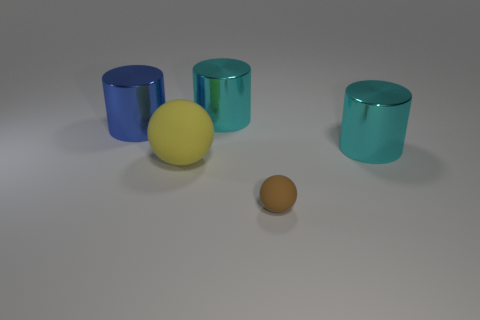Subtract all big blue cylinders. How many cylinders are left? 2 Add 4 large yellow rubber spheres. How many objects exist? 9 Subtract all yellow spheres. How many spheres are left? 1 Subtract all cyan spheres. How many cyan cylinders are left? 2 Subtract all balls. How many objects are left? 3 Subtract 1 cylinders. How many cylinders are left? 2 Subtract all green cylinders. Subtract all brown cubes. How many cylinders are left? 3 Subtract all brown matte objects. Subtract all big yellow matte cubes. How many objects are left? 4 Add 4 brown objects. How many brown objects are left? 5 Add 4 tiny matte things. How many tiny matte things exist? 5 